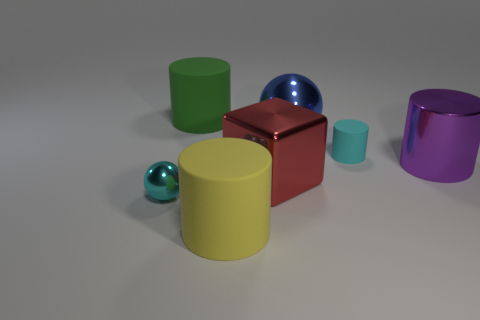The yellow rubber object that is the same size as the red shiny block is what shape?
Provide a short and direct response. Cylinder. Are there more big yellow objects than gray cylinders?
Make the answer very short. Yes. Is there a large object in front of the ball behind the small sphere?
Give a very brief answer. Yes. The other tiny object that is the same shape as the yellow object is what color?
Make the answer very short. Cyan. Are there any other things that are the same shape as the big red shiny thing?
Give a very brief answer. No. What color is the cylinder that is the same material as the red cube?
Offer a terse response. Purple. There is a tiny thing in front of the small object that is to the right of the big green rubber cylinder; are there any tiny things that are right of it?
Make the answer very short. Yes. Are there fewer cyan rubber objects in front of the tiny shiny object than big things that are behind the small cyan matte cylinder?
Keep it short and to the point. Yes. How many large red blocks have the same material as the purple object?
Offer a very short reply. 1. There is a green rubber cylinder; does it have the same size as the ball behind the purple shiny object?
Make the answer very short. Yes. 